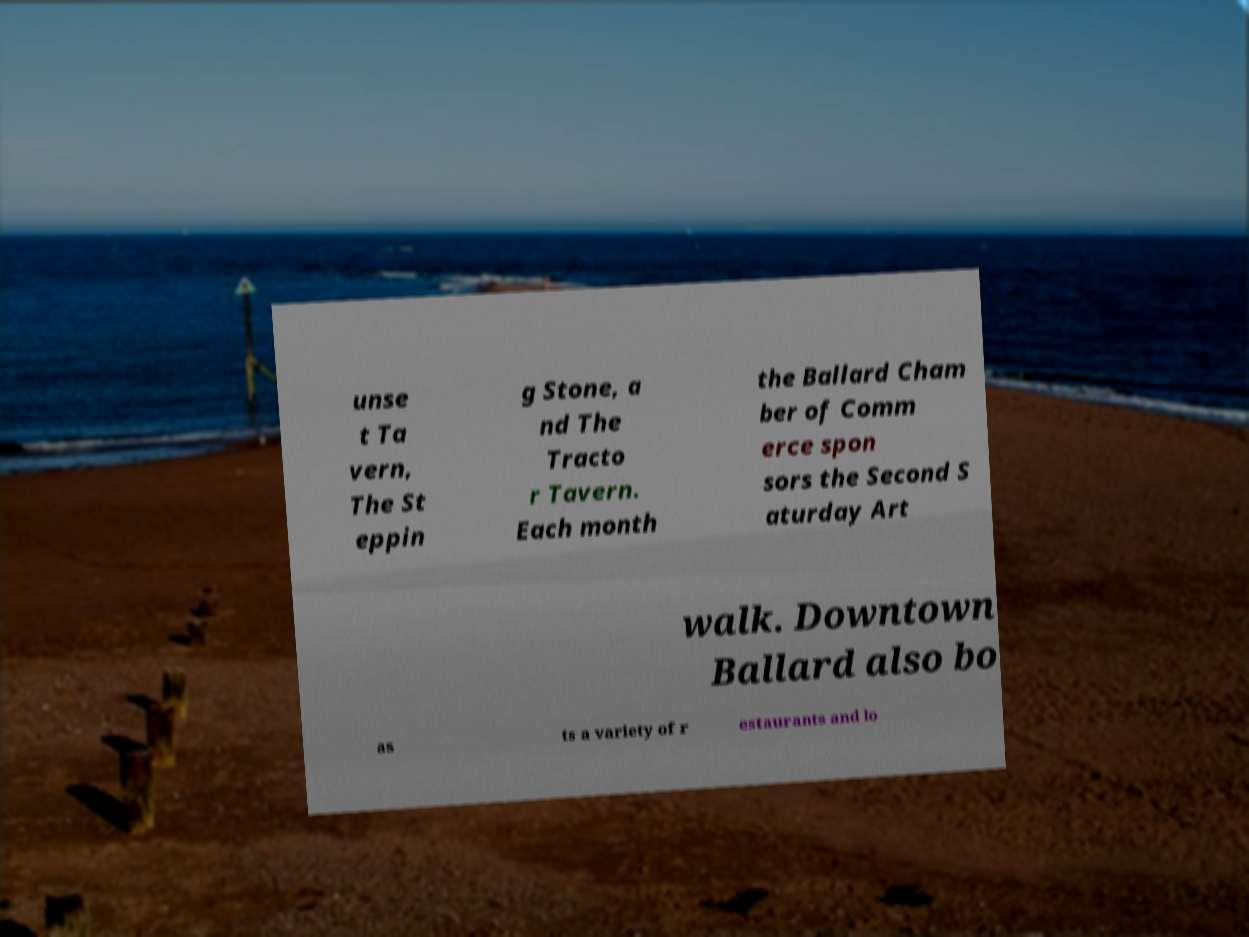Please read and relay the text visible in this image. What does it say? unse t Ta vern, The St eppin g Stone, a nd The Tracto r Tavern. Each month the Ballard Cham ber of Comm erce spon sors the Second S aturday Art walk. Downtown Ballard also bo as ts a variety of r estaurants and lo 